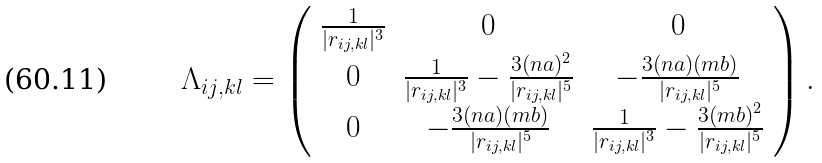<formula> <loc_0><loc_0><loc_500><loc_500>\Lambda _ { i j , k l } = \left ( \begin{array} { c c c } \frac { 1 } { | { r } _ { i j , k l } | ^ { 3 } } & 0 & 0 \\ 0 & \frac { 1 } { | { r } _ { i j , k l } | ^ { 3 } } - \frac { 3 ( n a ) ^ { 2 } } { | { r } _ { i j , k l } | ^ { 5 } } & - \frac { 3 ( n a ) ( m b ) } { | { r } _ { i j , k l } | ^ { 5 } } \\ 0 & - \frac { 3 ( n a ) ( m b ) } { | { r } _ { i j , k l } | ^ { 5 } } & \frac { 1 } { | { r } _ { i j , k l } | ^ { 3 } } - \frac { 3 ( m b ) ^ { 2 } } { | { r } _ { i j , k l } | ^ { 5 } } \end{array} \right ) .</formula> 